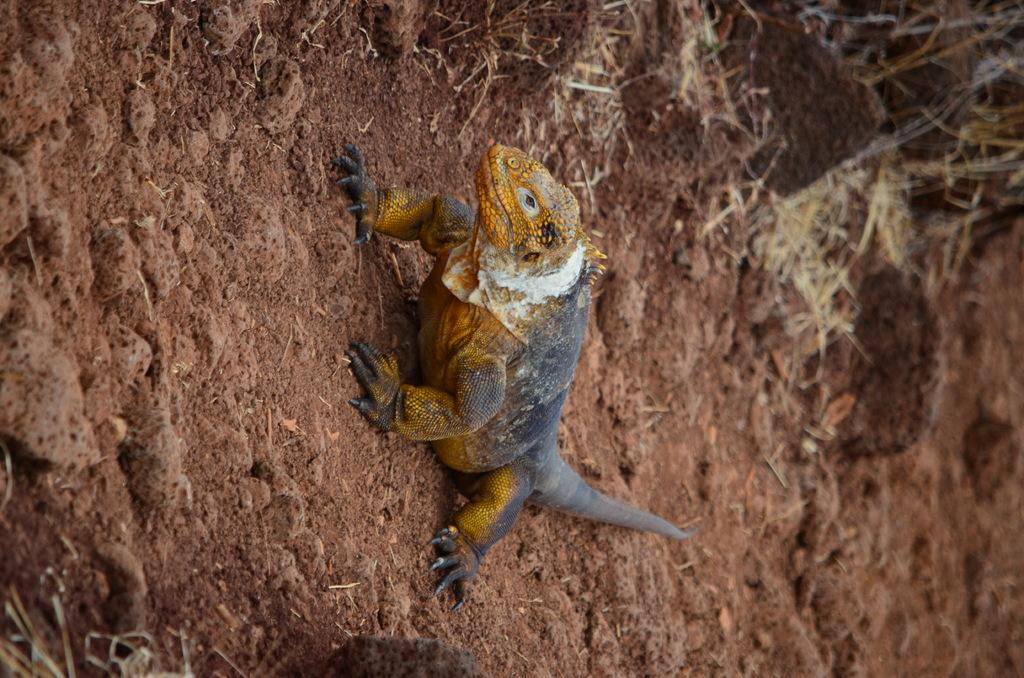What type of animal is in the image? There is a lizard in the image. What colors can be seen on the lizard? The lizard is yellow, black, and white in color. Where is the lizard located in the image? The lizard is on the mud. What type of vegetation is visible in the image? There is grass visible in the image. What magical substance is the lizard using to levitate in the image? There is no magical substance or levitation present in the image; the lizard is on the mud. Is there a carriage visible in the image? No, there is no carriage present in the image. 